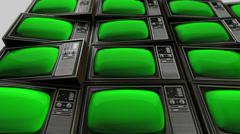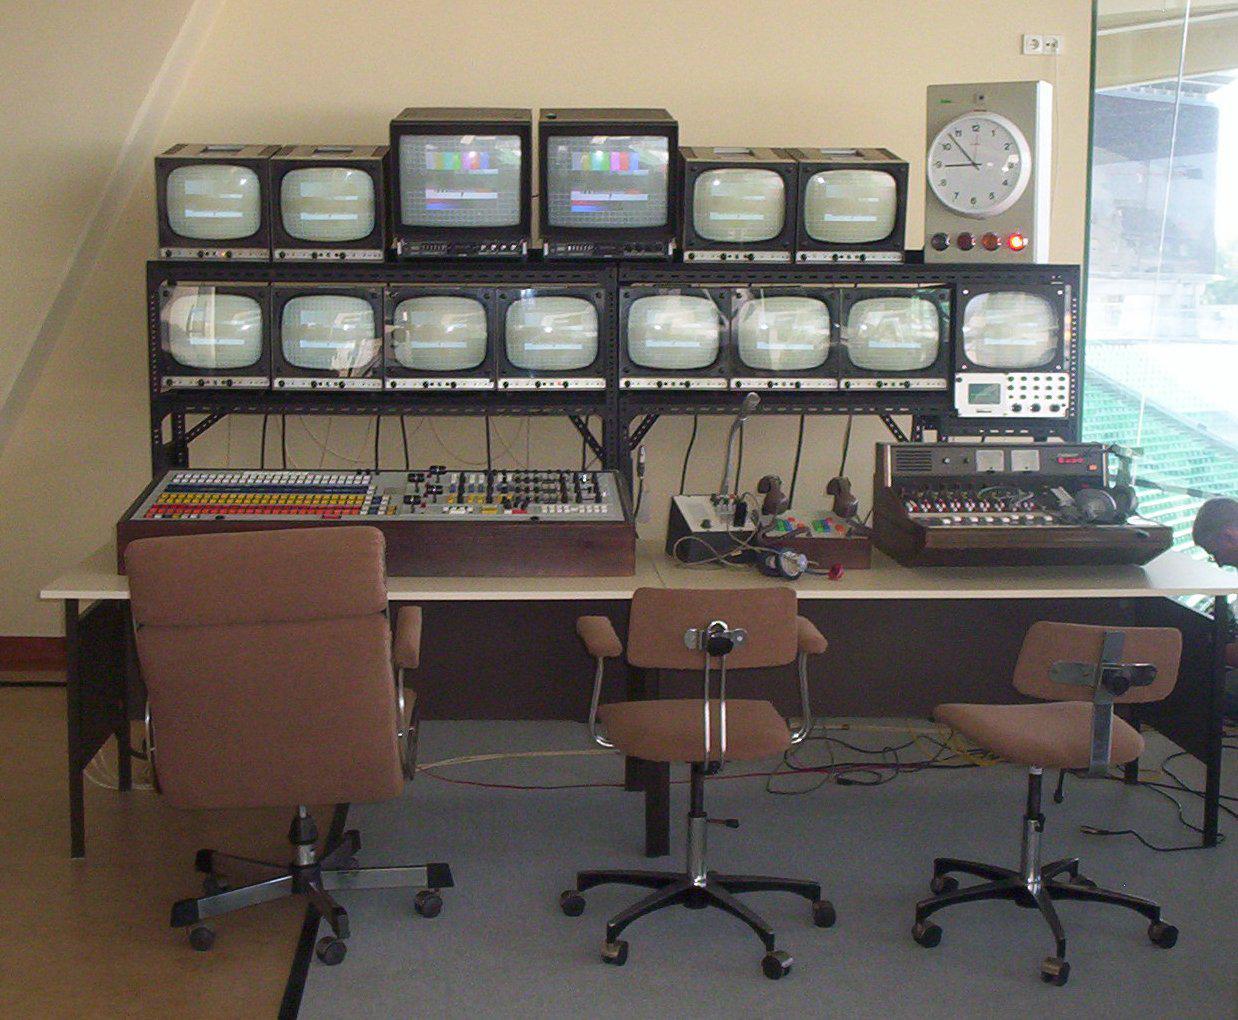The first image is the image on the left, the second image is the image on the right. Examine the images to the left and right. Is the description "The left image contains at least one old-fashioned TV with controls to the right of a slightly rounded square screen, which is glowing green." accurate? Answer yes or no. Yes. The first image is the image on the left, the second image is the image on the right. Considering the images on both sides, is "At least one television's display is bright green." valid? Answer yes or no. Yes. 